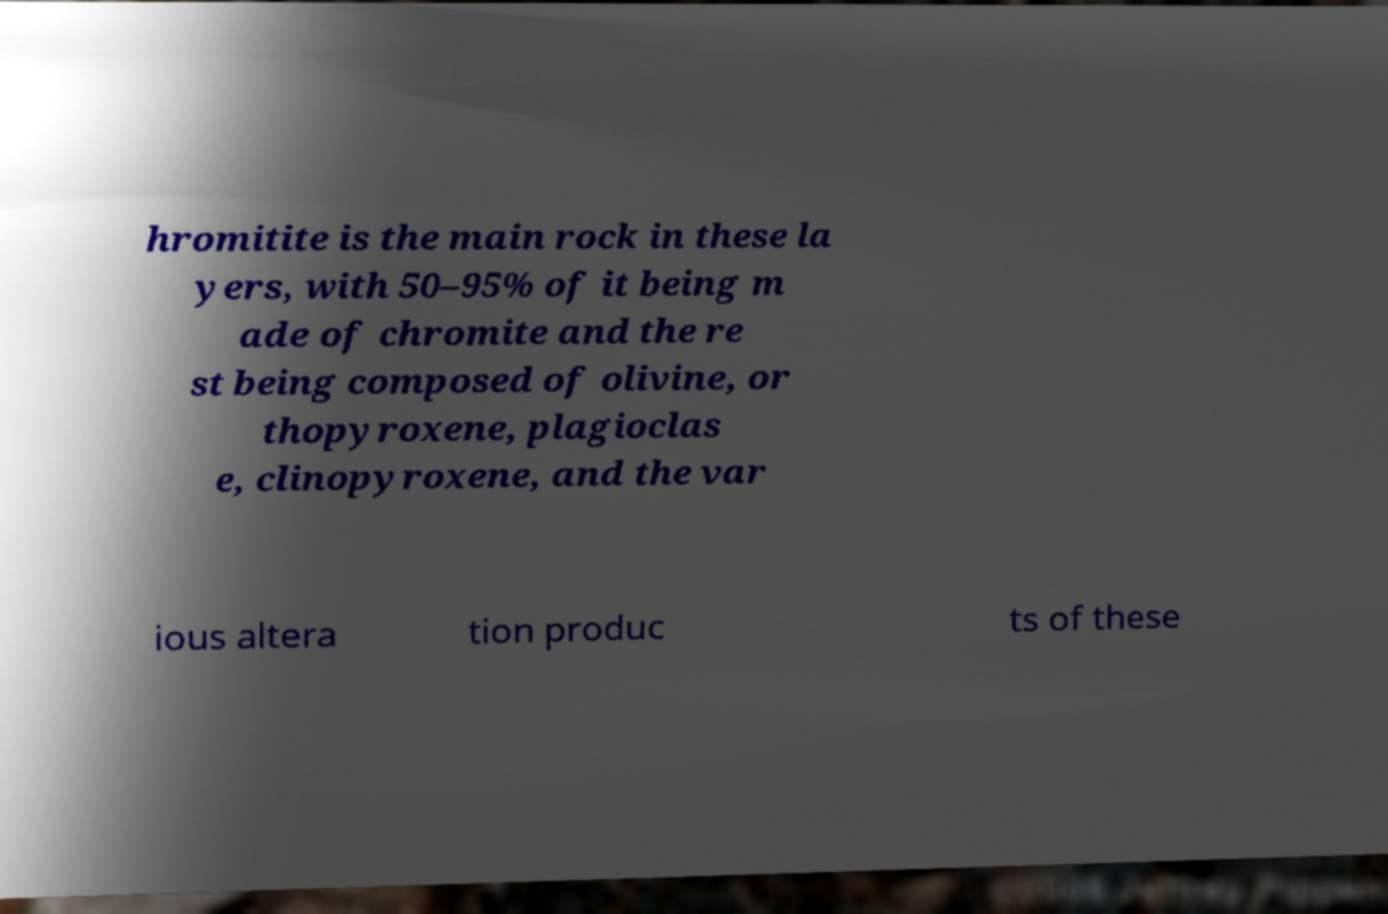I need the written content from this picture converted into text. Can you do that? hromitite is the main rock in these la yers, with 50–95% of it being m ade of chromite and the re st being composed of olivine, or thopyroxene, plagioclas e, clinopyroxene, and the var ious altera tion produc ts of these 